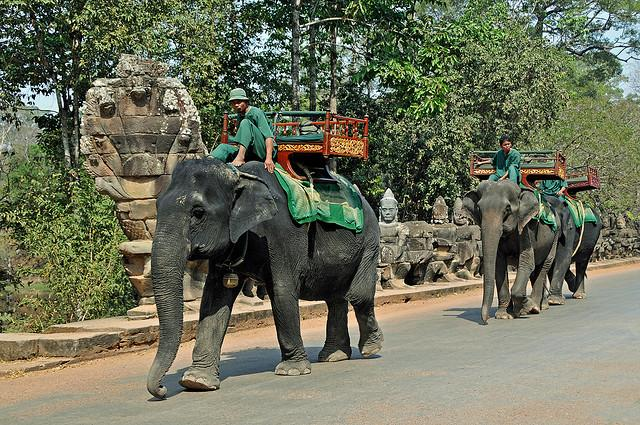Which country is famous for elephants? india 